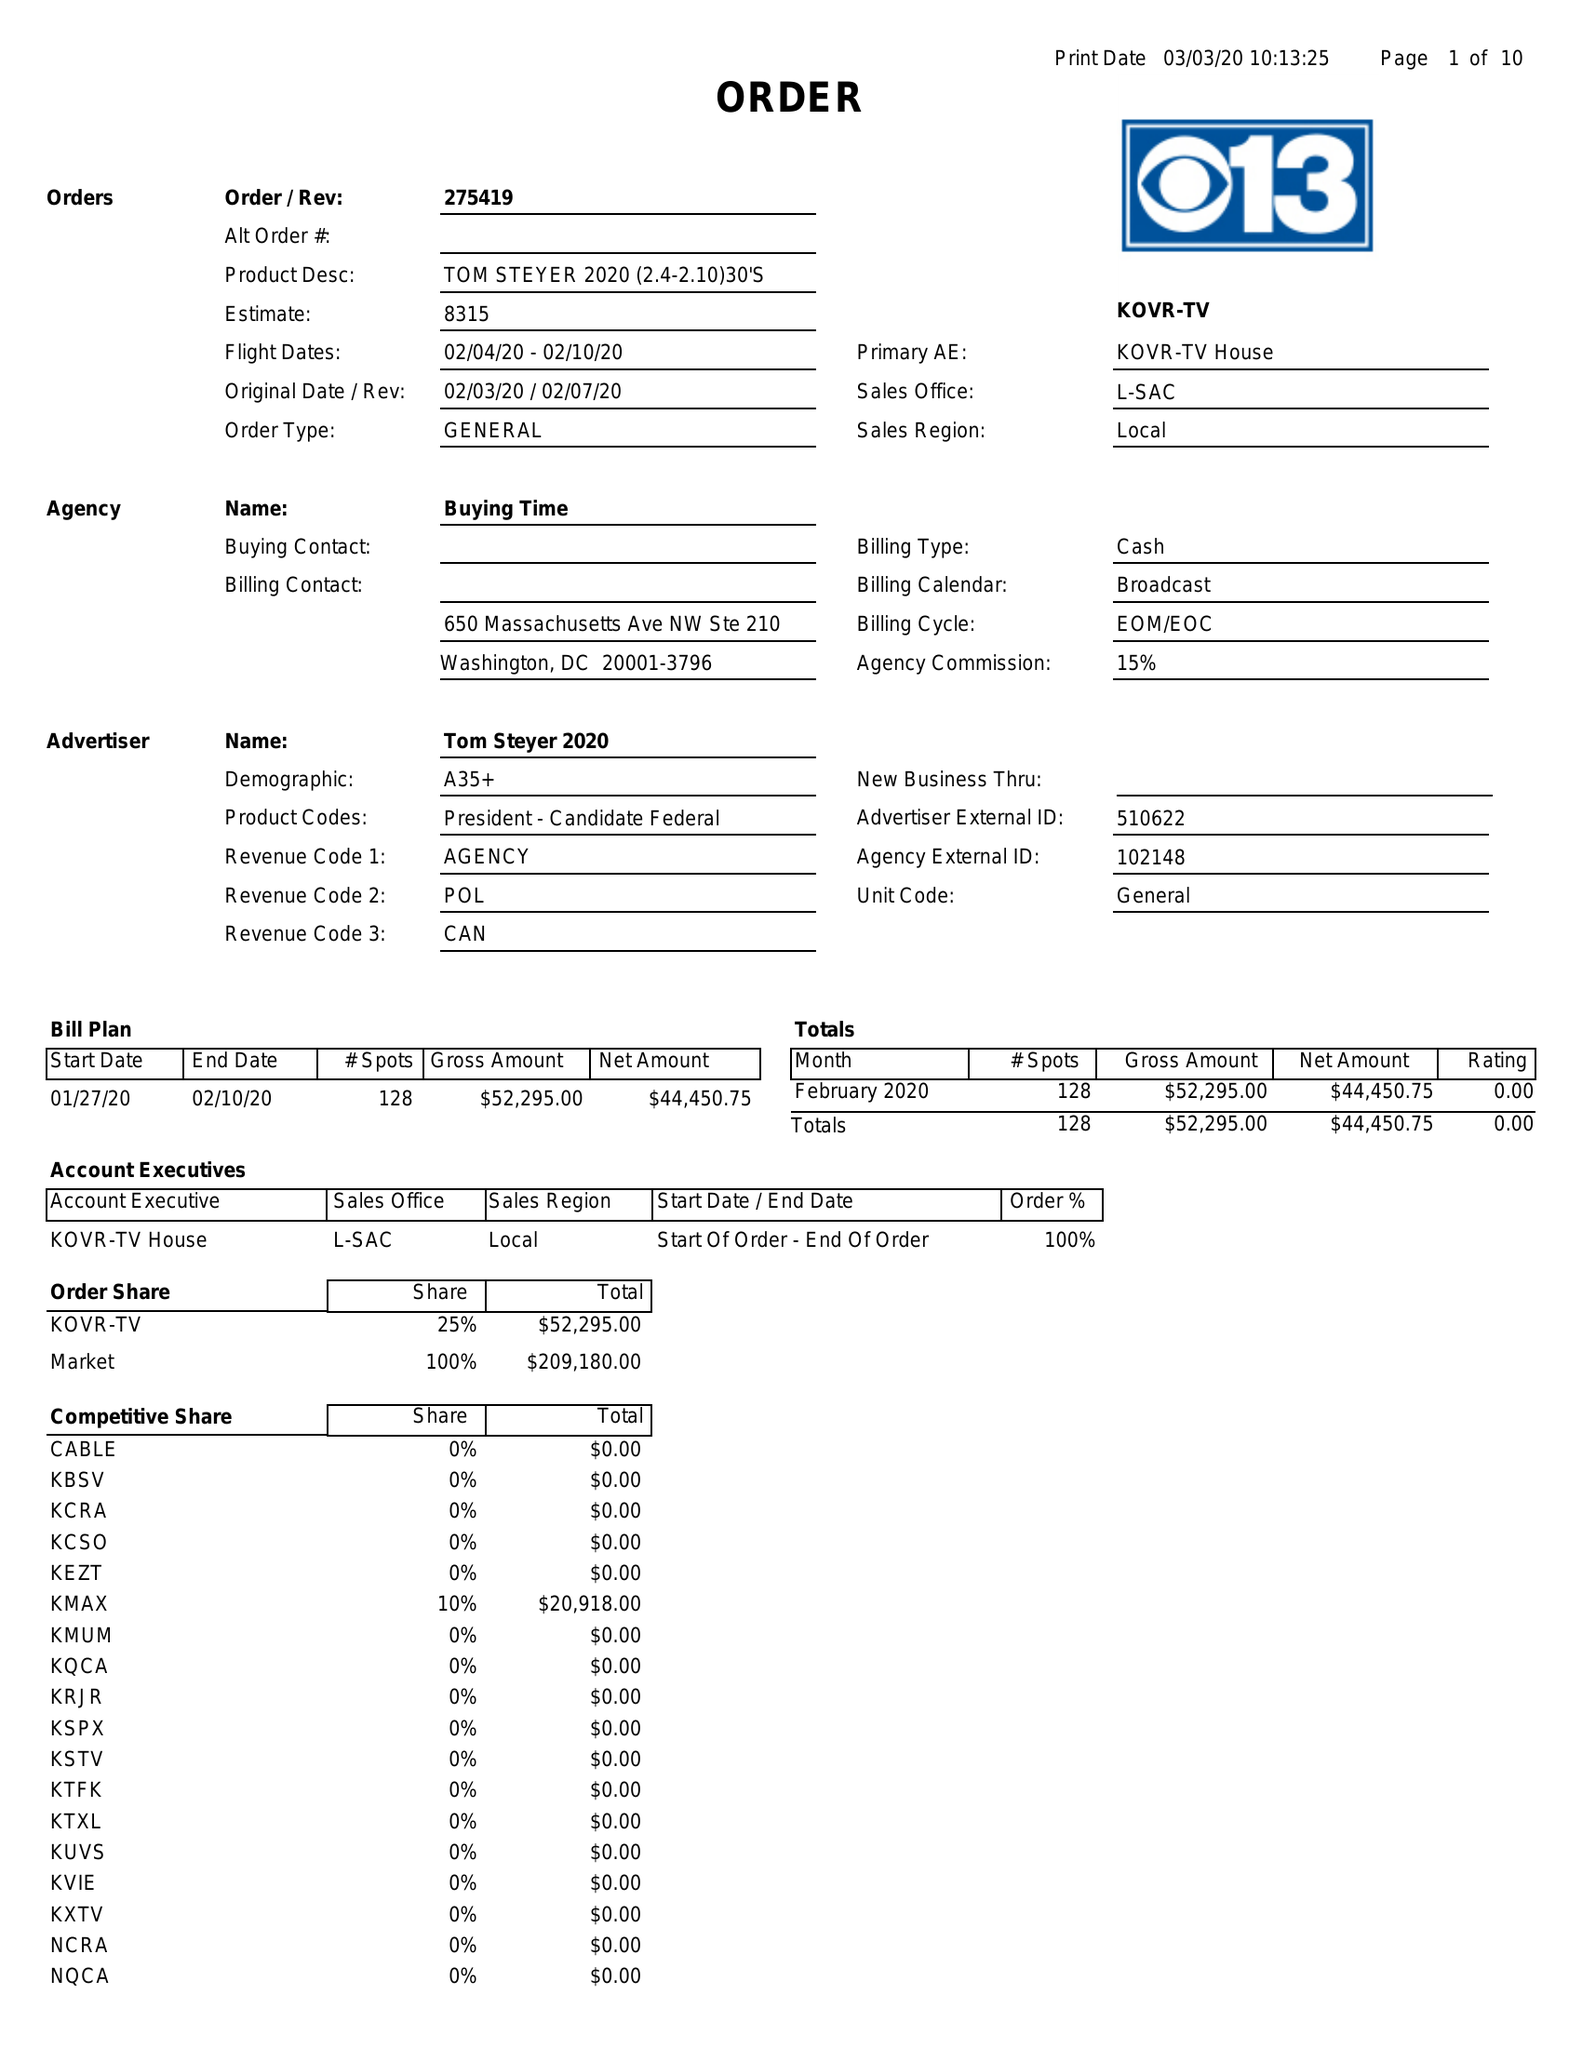What is the value for the contract_num?
Answer the question using a single word or phrase. 275419 